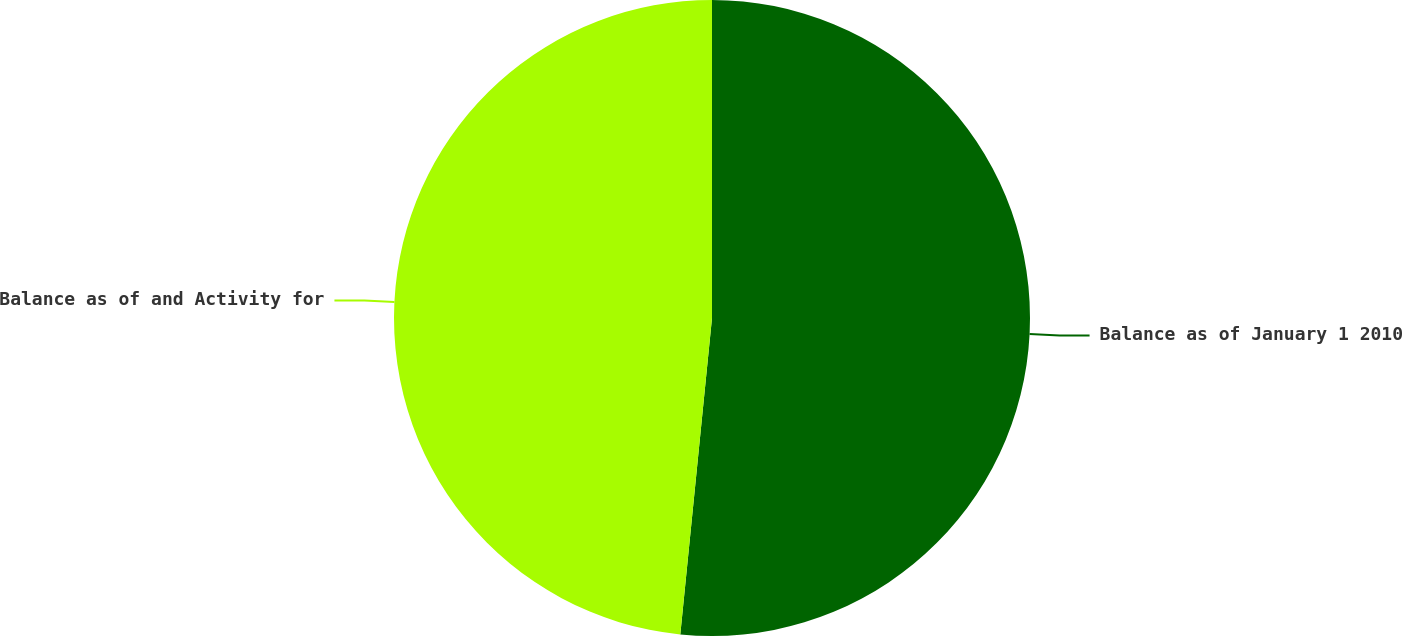<chart> <loc_0><loc_0><loc_500><loc_500><pie_chart><fcel>Balance as of January 1 2010<fcel>Balance as of and Activity for<nl><fcel>51.59%<fcel>48.41%<nl></chart> 